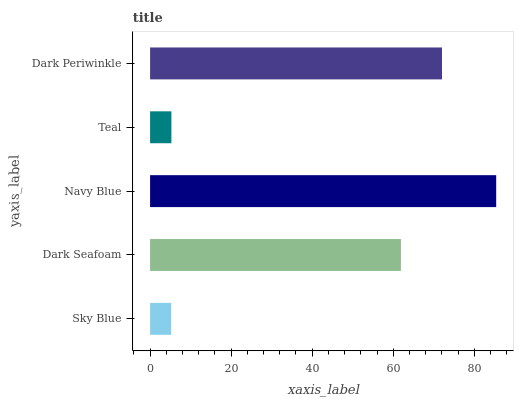Is Sky Blue the minimum?
Answer yes or no. Yes. Is Navy Blue the maximum?
Answer yes or no. Yes. Is Dark Seafoam the minimum?
Answer yes or no. No. Is Dark Seafoam the maximum?
Answer yes or no. No. Is Dark Seafoam greater than Sky Blue?
Answer yes or no. Yes. Is Sky Blue less than Dark Seafoam?
Answer yes or no. Yes. Is Sky Blue greater than Dark Seafoam?
Answer yes or no. No. Is Dark Seafoam less than Sky Blue?
Answer yes or no. No. Is Dark Seafoam the high median?
Answer yes or no. Yes. Is Dark Seafoam the low median?
Answer yes or no. Yes. Is Dark Periwinkle the high median?
Answer yes or no. No. Is Navy Blue the low median?
Answer yes or no. No. 